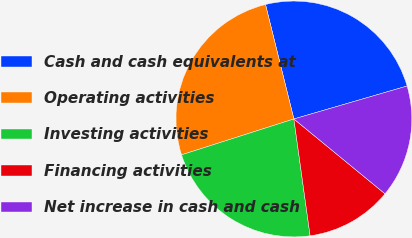Convert chart. <chart><loc_0><loc_0><loc_500><loc_500><pie_chart><fcel>Cash and cash equivalents at<fcel>Operating activities<fcel>Investing activities<fcel>Financing activities<fcel>Net increase in cash and cash<nl><fcel>24.36%<fcel>26.05%<fcel>22.28%<fcel>11.86%<fcel>15.45%<nl></chart> 